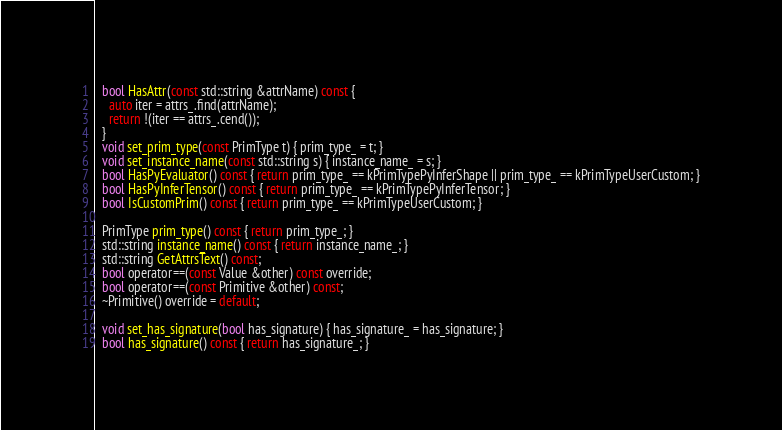<code> <loc_0><loc_0><loc_500><loc_500><_C_>  bool HasAttr(const std::string &attrName) const {
    auto iter = attrs_.find(attrName);
    return !(iter == attrs_.cend());
  }
  void set_prim_type(const PrimType t) { prim_type_ = t; }
  void set_instance_name(const std::string s) { instance_name_ = s; }
  bool HasPyEvaluator() const { return prim_type_ == kPrimTypePyInferShape || prim_type_ == kPrimTypeUserCustom; }
  bool HasPyInferTensor() const { return prim_type_ == kPrimTypePyInferTensor; }
  bool IsCustomPrim() const { return prim_type_ == kPrimTypeUserCustom; }

  PrimType prim_type() const { return prim_type_; }
  std::string instance_name() const { return instance_name_; }
  std::string GetAttrsText() const;
  bool operator==(const Value &other) const override;
  bool operator==(const Primitive &other) const;
  ~Primitive() override = default;

  void set_has_signature(bool has_signature) { has_signature_ = has_signature; }
  bool has_signature() const { return has_signature_; }</code> 